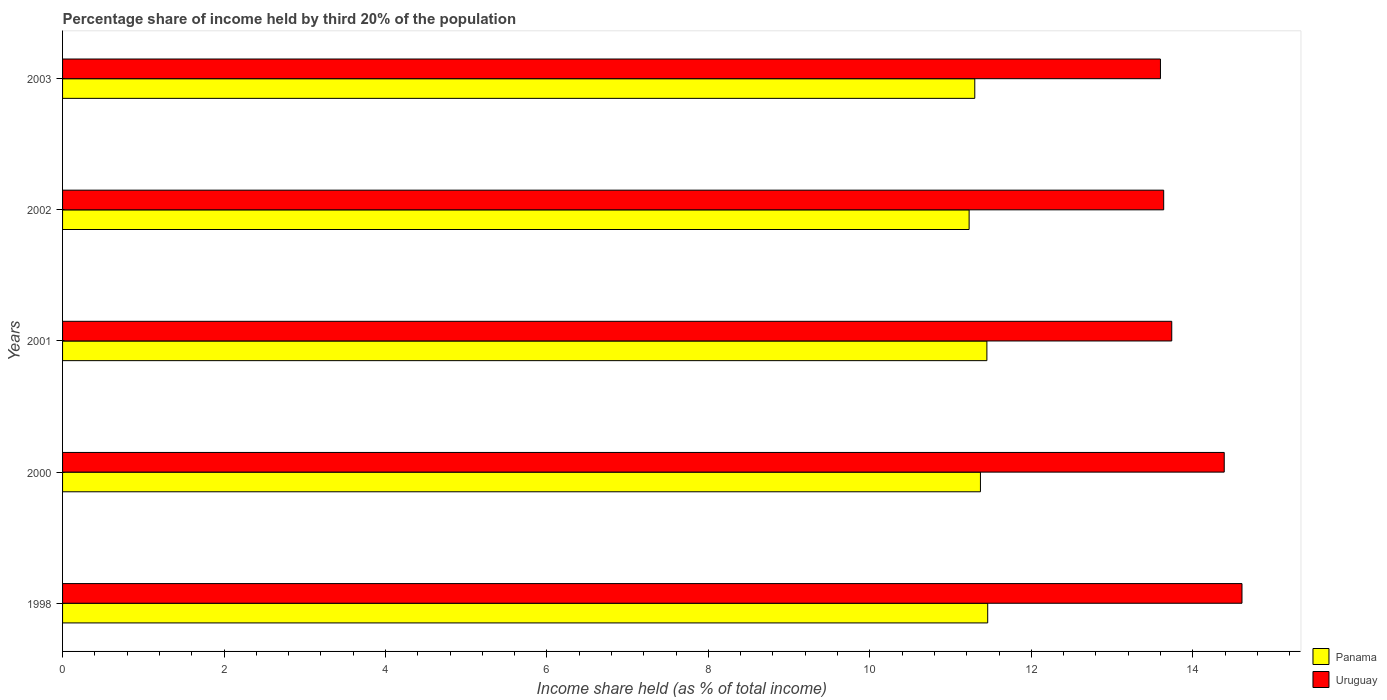How many different coloured bars are there?
Keep it short and to the point. 2. How many groups of bars are there?
Your response must be concise. 5. How many bars are there on the 2nd tick from the top?
Give a very brief answer. 2. What is the label of the 5th group of bars from the top?
Your response must be concise. 1998. What is the share of income held by third 20% of the population in Uruguay in 2001?
Provide a short and direct response. 13.74. Across all years, what is the maximum share of income held by third 20% of the population in Uruguay?
Offer a very short reply. 14.61. Across all years, what is the minimum share of income held by third 20% of the population in Panama?
Ensure brevity in your answer.  11.23. In which year was the share of income held by third 20% of the population in Panama minimum?
Offer a terse response. 2002. What is the total share of income held by third 20% of the population in Uruguay in the graph?
Make the answer very short. 69.98. What is the difference between the share of income held by third 20% of the population in Uruguay in 2000 and that in 2002?
Make the answer very short. 0.75. What is the difference between the share of income held by third 20% of the population in Uruguay in 2000 and the share of income held by third 20% of the population in Panama in 1998?
Ensure brevity in your answer.  2.93. What is the average share of income held by third 20% of the population in Uruguay per year?
Ensure brevity in your answer.  14. In the year 2000, what is the difference between the share of income held by third 20% of the population in Panama and share of income held by third 20% of the population in Uruguay?
Provide a succinct answer. -3.02. In how many years, is the share of income held by third 20% of the population in Panama greater than 9.6 %?
Offer a very short reply. 5. What is the ratio of the share of income held by third 20% of the population in Uruguay in 2001 to that in 2003?
Offer a terse response. 1.01. Is the share of income held by third 20% of the population in Panama in 2000 less than that in 2001?
Your answer should be very brief. Yes. What is the difference between the highest and the second highest share of income held by third 20% of the population in Uruguay?
Your answer should be compact. 0.22. What is the difference between the highest and the lowest share of income held by third 20% of the population in Panama?
Keep it short and to the point. 0.23. In how many years, is the share of income held by third 20% of the population in Panama greater than the average share of income held by third 20% of the population in Panama taken over all years?
Offer a terse response. 3. What does the 1st bar from the top in 2003 represents?
Your answer should be very brief. Uruguay. What does the 2nd bar from the bottom in 2000 represents?
Your answer should be very brief. Uruguay. What is the difference between two consecutive major ticks on the X-axis?
Ensure brevity in your answer.  2. Are the values on the major ticks of X-axis written in scientific E-notation?
Offer a very short reply. No. Does the graph contain any zero values?
Offer a very short reply. No. Does the graph contain grids?
Offer a terse response. No. Where does the legend appear in the graph?
Provide a short and direct response. Bottom right. What is the title of the graph?
Your answer should be compact. Percentage share of income held by third 20% of the population. Does "Mongolia" appear as one of the legend labels in the graph?
Keep it short and to the point. No. What is the label or title of the X-axis?
Make the answer very short. Income share held (as % of total income). What is the Income share held (as % of total income) of Panama in 1998?
Your answer should be very brief. 11.46. What is the Income share held (as % of total income) of Uruguay in 1998?
Make the answer very short. 14.61. What is the Income share held (as % of total income) in Panama in 2000?
Give a very brief answer. 11.37. What is the Income share held (as % of total income) of Uruguay in 2000?
Offer a very short reply. 14.39. What is the Income share held (as % of total income) in Panama in 2001?
Your response must be concise. 11.45. What is the Income share held (as % of total income) in Uruguay in 2001?
Offer a terse response. 13.74. What is the Income share held (as % of total income) of Panama in 2002?
Provide a succinct answer. 11.23. What is the Income share held (as % of total income) in Uruguay in 2002?
Make the answer very short. 13.64. What is the Income share held (as % of total income) in Panama in 2003?
Provide a short and direct response. 11.3. What is the Income share held (as % of total income) of Uruguay in 2003?
Provide a succinct answer. 13.6. Across all years, what is the maximum Income share held (as % of total income) in Panama?
Offer a very short reply. 11.46. Across all years, what is the maximum Income share held (as % of total income) in Uruguay?
Ensure brevity in your answer.  14.61. Across all years, what is the minimum Income share held (as % of total income) in Panama?
Offer a terse response. 11.23. Across all years, what is the minimum Income share held (as % of total income) in Uruguay?
Offer a very short reply. 13.6. What is the total Income share held (as % of total income) of Panama in the graph?
Give a very brief answer. 56.81. What is the total Income share held (as % of total income) of Uruguay in the graph?
Your answer should be very brief. 69.98. What is the difference between the Income share held (as % of total income) in Panama in 1998 and that in 2000?
Provide a succinct answer. 0.09. What is the difference between the Income share held (as % of total income) in Uruguay in 1998 and that in 2000?
Ensure brevity in your answer.  0.22. What is the difference between the Income share held (as % of total income) in Panama in 1998 and that in 2001?
Keep it short and to the point. 0.01. What is the difference between the Income share held (as % of total income) of Uruguay in 1998 and that in 2001?
Offer a terse response. 0.87. What is the difference between the Income share held (as % of total income) in Panama in 1998 and that in 2002?
Offer a very short reply. 0.23. What is the difference between the Income share held (as % of total income) in Panama in 1998 and that in 2003?
Ensure brevity in your answer.  0.16. What is the difference between the Income share held (as % of total income) in Uruguay in 1998 and that in 2003?
Your answer should be very brief. 1.01. What is the difference between the Income share held (as % of total income) of Panama in 2000 and that in 2001?
Provide a succinct answer. -0.08. What is the difference between the Income share held (as % of total income) in Uruguay in 2000 and that in 2001?
Keep it short and to the point. 0.65. What is the difference between the Income share held (as % of total income) of Panama in 2000 and that in 2002?
Offer a very short reply. 0.14. What is the difference between the Income share held (as % of total income) of Panama in 2000 and that in 2003?
Your response must be concise. 0.07. What is the difference between the Income share held (as % of total income) of Uruguay in 2000 and that in 2003?
Keep it short and to the point. 0.79. What is the difference between the Income share held (as % of total income) in Panama in 2001 and that in 2002?
Your response must be concise. 0.22. What is the difference between the Income share held (as % of total income) in Uruguay in 2001 and that in 2003?
Provide a succinct answer. 0.14. What is the difference between the Income share held (as % of total income) of Panama in 2002 and that in 2003?
Give a very brief answer. -0.07. What is the difference between the Income share held (as % of total income) of Panama in 1998 and the Income share held (as % of total income) of Uruguay in 2000?
Make the answer very short. -2.93. What is the difference between the Income share held (as % of total income) of Panama in 1998 and the Income share held (as % of total income) of Uruguay in 2001?
Your answer should be compact. -2.28. What is the difference between the Income share held (as % of total income) in Panama in 1998 and the Income share held (as % of total income) in Uruguay in 2002?
Give a very brief answer. -2.18. What is the difference between the Income share held (as % of total income) of Panama in 1998 and the Income share held (as % of total income) of Uruguay in 2003?
Offer a terse response. -2.14. What is the difference between the Income share held (as % of total income) in Panama in 2000 and the Income share held (as % of total income) in Uruguay in 2001?
Offer a terse response. -2.37. What is the difference between the Income share held (as % of total income) in Panama in 2000 and the Income share held (as % of total income) in Uruguay in 2002?
Offer a very short reply. -2.27. What is the difference between the Income share held (as % of total income) of Panama in 2000 and the Income share held (as % of total income) of Uruguay in 2003?
Your answer should be very brief. -2.23. What is the difference between the Income share held (as % of total income) of Panama in 2001 and the Income share held (as % of total income) of Uruguay in 2002?
Keep it short and to the point. -2.19. What is the difference between the Income share held (as % of total income) in Panama in 2001 and the Income share held (as % of total income) in Uruguay in 2003?
Provide a short and direct response. -2.15. What is the difference between the Income share held (as % of total income) of Panama in 2002 and the Income share held (as % of total income) of Uruguay in 2003?
Give a very brief answer. -2.37. What is the average Income share held (as % of total income) of Panama per year?
Offer a very short reply. 11.36. What is the average Income share held (as % of total income) in Uruguay per year?
Provide a short and direct response. 14. In the year 1998, what is the difference between the Income share held (as % of total income) in Panama and Income share held (as % of total income) in Uruguay?
Your response must be concise. -3.15. In the year 2000, what is the difference between the Income share held (as % of total income) in Panama and Income share held (as % of total income) in Uruguay?
Provide a short and direct response. -3.02. In the year 2001, what is the difference between the Income share held (as % of total income) of Panama and Income share held (as % of total income) of Uruguay?
Your response must be concise. -2.29. In the year 2002, what is the difference between the Income share held (as % of total income) in Panama and Income share held (as % of total income) in Uruguay?
Provide a succinct answer. -2.41. In the year 2003, what is the difference between the Income share held (as % of total income) of Panama and Income share held (as % of total income) of Uruguay?
Offer a terse response. -2.3. What is the ratio of the Income share held (as % of total income) of Panama in 1998 to that in 2000?
Provide a succinct answer. 1.01. What is the ratio of the Income share held (as % of total income) in Uruguay in 1998 to that in 2000?
Offer a very short reply. 1.02. What is the ratio of the Income share held (as % of total income) in Uruguay in 1998 to that in 2001?
Ensure brevity in your answer.  1.06. What is the ratio of the Income share held (as % of total income) in Panama in 1998 to that in 2002?
Provide a succinct answer. 1.02. What is the ratio of the Income share held (as % of total income) in Uruguay in 1998 to that in 2002?
Offer a very short reply. 1.07. What is the ratio of the Income share held (as % of total income) of Panama in 1998 to that in 2003?
Offer a very short reply. 1.01. What is the ratio of the Income share held (as % of total income) of Uruguay in 1998 to that in 2003?
Ensure brevity in your answer.  1.07. What is the ratio of the Income share held (as % of total income) of Panama in 2000 to that in 2001?
Provide a succinct answer. 0.99. What is the ratio of the Income share held (as % of total income) in Uruguay in 2000 to that in 2001?
Keep it short and to the point. 1.05. What is the ratio of the Income share held (as % of total income) of Panama in 2000 to that in 2002?
Ensure brevity in your answer.  1.01. What is the ratio of the Income share held (as % of total income) of Uruguay in 2000 to that in 2002?
Give a very brief answer. 1.05. What is the ratio of the Income share held (as % of total income) in Uruguay in 2000 to that in 2003?
Your answer should be compact. 1.06. What is the ratio of the Income share held (as % of total income) of Panama in 2001 to that in 2002?
Your answer should be compact. 1.02. What is the ratio of the Income share held (as % of total income) in Uruguay in 2001 to that in 2002?
Your answer should be very brief. 1.01. What is the ratio of the Income share held (as % of total income) of Panama in 2001 to that in 2003?
Provide a succinct answer. 1.01. What is the ratio of the Income share held (as % of total income) of Uruguay in 2001 to that in 2003?
Provide a short and direct response. 1.01. What is the ratio of the Income share held (as % of total income) of Panama in 2002 to that in 2003?
Provide a succinct answer. 0.99. What is the ratio of the Income share held (as % of total income) in Uruguay in 2002 to that in 2003?
Offer a very short reply. 1. What is the difference between the highest and the second highest Income share held (as % of total income) of Panama?
Keep it short and to the point. 0.01. What is the difference between the highest and the second highest Income share held (as % of total income) of Uruguay?
Provide a succinct answer. 0.22. What is the difference between the highest and the lowest Income share held (as % of total income) of Panama?
Keep it short and to the point. 0.23. What is the difference between the highest and the lowest Income share held (as % of total income) of Uruguay?
Your answer should be compact. 1.01. 